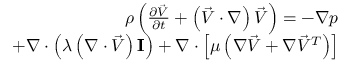<formula> <loc_0><loc_0><loc_500><loc_500>\begin{array} { r l r } & { \rho \left ( \frac { \partial \vec { V } } { \partial t } + \left ( \vec { V } \cdot \nabla \right ) \vec { V } \right ) = - \nabla p } \\ & { + \nabla \cdot \left ( \lambda \left ( \nabla \cdot \vec { V } \right ) I \right ) + \nabla \cdot \left [ \mu \left ( \nabla \vec { V } + \nabla \vec { V } ^ { T } \right ) \right ] } \end{array}</formula> 